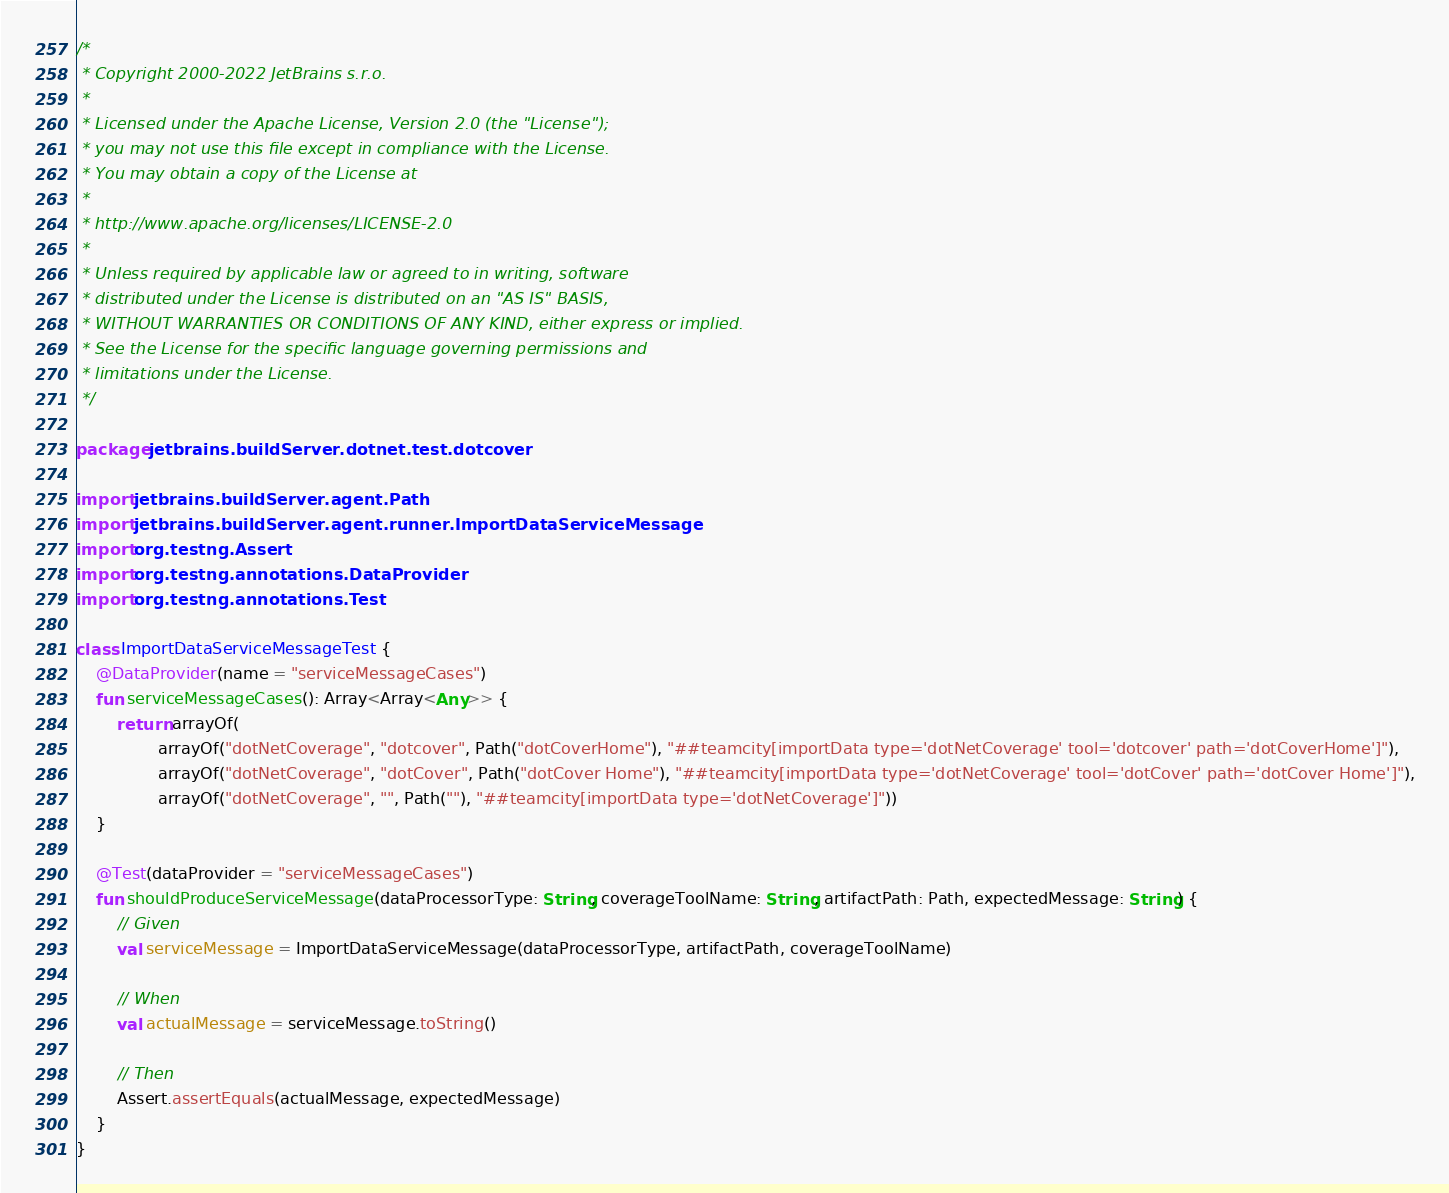Convert code to text. <code><loc_0><loc_0><loc_500><loc_500><_Kotlin_>/*
 * Copyright 2000-2022 JetBrains s.r.o.
 *
 * Licensed under the Apache License, Version 2.0 (the "License");
 * you may not use this file except in compliance with the License.
 * You may obtain a copy of the License at
 *
 * http://www.apache.org/licenses/LICENSE-2.0
 *
 * Unless required by applicable law or agreed to in writing, software
 * distributed under the License is distributed on an "AS IS" BASIS,
 * WITHOUT WARRANTIES OR CONDITIONS OF ANY KIND, either express or implied.
 * See the License for the specific language governing permissions and
 * limitations under the License.
 */

package jetbrains.buildServer.dotnet.test.dotcover

import jetbrains.buildServer.agent.Path
import jetbrains.buildServer.agent.runner.ImportDataServiceMessage
import org.testng.Assert
import org.testng.annotations.DataProvider
import org.testng.annotations.Test

class ImportDataServiceMessageTest {
    @DataProvider(name = "serviceMessageCases")
    fun serviceMessageCases(): Array<Array<Any>> {
        return arrayOf(
                arrayOf("dotNetCoverage", "dotcover", Path("dotCoverHome"), "##teamcity[importData type='dotNetCoverage' tool='dotcover' path='dotCoverHome']"),
                arrayOf("dotNetCoverage", "dotCover", Path("dotCover Home"), "##teamcity[importData type='dotNetCoverage' tool='dotCover' path='dotCover Home']"),
                arrayOf("dotNetCoverage", "", Path(""), "##teamcity[importData type='dotNetCoverage']"))
    }

    @Test(dataProvider = "serviceMessageCases")
    fun shouldProduceServiceMessage(dataProcessorType: String, coverageToolName: String, artifactPath: Path, expectedMessage: String) {
        // Given
        val serviceMessage = ImportDataServiceMessage(dataProcessorType, artifactPath, coverageToolName)

        // When
        val actualMessage = serviceMessage.toString()

        // Then
        Assert.assertEquals(actualMessage, expectedMessage)
    }
}</code> 